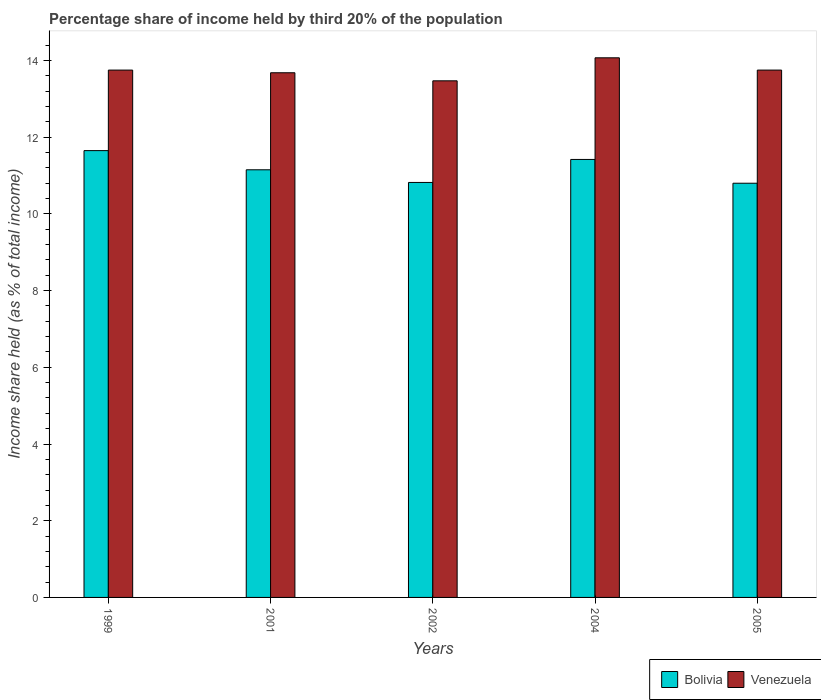How many different coloured bars are there?
Your response must be concise. 2. How many groups of bars are there?
Provide a short and direct response. 5. Are the number of bars on each tick of the X-axis equal?
Provide a short and direct response. Yes. How many bars are there on the 2nd tick from the left?
Provide a short and direct response. 2. What is the label of the 4th group of bars from the left?
Provide a succinct answer. 2004. In how many cases, is the number of bars for a given year not equal to the number of legend labels?
Your answer should be compact. 0. What is the share of income held by third 20% of the population in Bolivia in 2004?
Your answer should be compact. 11.42. Across all years, what is the maximum share of income held by third 20% of the population in Venezuela?
Keep it short and to the point. 14.07. In which year was the share of income held by third 20% of the population in Venezuela minimum?
Offer a very short reply. 2002. What is the total share of income held by third 20% of the population in Bolivia in the graph?
Give a very brief answer. 55.84. What is the difference between the share of income held by third 20% of the population in Venezuela in 1999 and that in 2002?
Offer a terse response. 0.28. What is the difference between the share of income held by third 20% of the population in Venezuela in 1999 and the share of income held by third 20% of the population in Bolivia in 2004?
Keep it short and to the point. 2.33. What is the average share of income held by third 20% of the population in Bolivia per year?
Your answer should be very brief. 11.17. In the year 2004, what is the difference between the share of income held by third 20% of the population in Venezuela and share of income held by third 20% of the population in Bolivia?
Provide a short and direct response. 2.65. In how many years, is the share of income held by third 20% of the population in Bolivia greater than 10 %?
Make the answer very short. 5. Is the share of income held by third 20% of the population in Venezuela in 2001 less than that in 2002?
Make the answer very short. No. What is the difference between the highest and the second highest share of income held by third 20% of the population in Venezuela?
Your answer should be very brief. 0.32. What is the difference between the highest and the lowest share of income held by third 20% of the population in Venezuela?
Provide a short and direct response. 0.6. In how many years, is the share of income held by third 20% of the population in Venezuela greater than the average share of income held by third 20% of the population in Venezuela taken over all years?
Provide a short and direct response. 3. What does the 2nd bar from the left in 2002 represents?
Offer a terse response. Venezuela. How many bars are there?
Offer a terse response. 10. What is the difference between two consecutive major ticks on the Y-axis?
Your answer should be very brief. 2. Does the graph contain any zero values?
Your answer should be compact. No. Where does the legend appear in the graph?
Your answer should be compact. Bottom right. How are the legend labels stacked?
Your answer should be compact. Horizontal. What is the title of the graph?
Offer a terse response. Percentage share of income held by third 20% of the population. What is the label or title of the Y-axis?
Ensure brevity in your answer.  Income share held (as % of total income). What is the Income share held (as % of total income) in Bolivia in 1999?
Provide a short and direct response. 11.65. What is the Income share held (as % of total income) in Venezuela in 1999?
Offer a terse response. 13.75. What is the Income share held (as % of total income) of Bolivia in 2001?
Provide a short and direct response. 11.15. What is the Income share held (as % of total income) of Venezuela in 2001?
Provide a short and direct response. 13.68. What is the Income share held (as % of total income) of Bolivia in 2002?
Provide a short and direct response. 10.82. What is the Income share held (as % of total income) of Venezuela in 2002?
Ensure brevity in your answer.  13.47. What is the Income share held (as % of total income) of Bolivia in 2004?
Offer a terse response. 11.42. What is the Income share held (as % of total income) in Venezuela in 2004?
Your answer should be very brief. 14.07. What is the Income share held (as % of total income) in Venezuela in 2005?
Provide a succinct answer. 13.75. Across all years, what is the maximum Income share held (as % of total income) of Bolivia?
Your response must be concise. 11.65. Across all years, what is the maximum Income share held (as % of total income) of Venezuela?
Your response must be concise. 14.07. Across all years, what is the minimum Income share held (as % of total income) in Bolivia?
Offer a very short reply. 10.8. Across all years, what is the minimum Income share held (as % of total income) in Venezuela?
Ensure brevity in your answer.  13.47. What is the total Income share held (as % of total income) of Bolivia in the graph?
Your response must be concise. 55.84. What is the total Income share held (as % of total income) in Venezuela in the graph?
Your answer should be compact. 68.72. What is the difference between the Income share held (as % of total income) in Venezuela in 1999 and that in 2001?
Give a very brief answer. 0.07. What is the difference between the Income share held (as % of total income) of Bolivia in 1999 and that in 2002?
Provide a succinct answer. 0.83. What is the difference between the Income share held (as % of total income) of Venezuela in 1999 and that in 2002?
Keep it short and to the point. 0.28. What is the difference between the Income share held (as % of total income) of Bolivia in 1999 and that in 2004?
Offer a terse response. 0.23. What is the difference between the Income share held (as % of total income) of Venezuela in 1999 and that in 2004?
Give a very brief answer. -0.32. What is the difference between the Income share held (as % of total income) in Bolivia in 2001 and that in 2002?
Your answer should be very brief. 0.33. What is the difference between the Income share held (as % of total income) of Venezuela in 2001 and that in 2002?
Offer a very short reply. 0.21. What is the difference between the Income share held (as % of total income) of Bolivia in 2001 and that in 2004?
Give a very brief answer. -0.27. What is the difference between the Income share held (as % of total income) in Venezuela in 2001 and that in 2004?
Give a very brief answer. -0.39. What is the difference between the Income share held (as % of total income) in Venezuela in 2001 and that in 2005?
Offer a terse response. -0.07. What is the difference between the Income share held (as % of total income) in Venezuela in 2002 and that in 2004?
Provide a short and direct response. -0.6. What is the difference between the Income share held (as % of total income) in Venezuela in 2002 and that in 2005?
Your answer should be compact. -0.28. What is the difference between the Income share held (as % of total income) in Bolivia in 2004 and that in 2005?
Your answer should be compact. 0.62. What is the difference between the Income share held (as % of total income) in Venezuela in 2004 and that in 2005?
Your answer should be compact. 0.32. What is the difference between the Income share held (as % of total income) in Bolivia in 1999 and the Income share held (as % of total income) in Venezuela in 2001?
Keep it short and to the point. -2.03. What is the difference between the Income share held (as % of total income) of Bolivia in 1999 and the Income share held (as % of total income) of Venezuela in 2002?
Offer a very short reply. -1.82. What is the difference between the Income share held (as % of total income) of Bolivia in 1999 and the Income share held (as % of total income) of Venezuela in 2004?
Keep it short and to the point. -2.42. What is the difference between the Income share held (as % of total income) in Bolivia in 1999 and the Income share held (as % of total income) in Venezuela in 2005?
Make the answer very short. -2.1. What is the difference between the Income share held (as % of total income) of Bolivia in 2001 and the Income share held (as % of total income) of Venezuela in 2002?
Ensure brevity in your answer.  -2.32. What is the difference between the Income share held (as % of total income) in Bolivia in 2001 and the Income share held (as % of total income) in Venezuela in 2004?
Your answer should be compact. -2.92. What is the difference between the Income share held (as % of total income) of Bolivia in 2002 and the Income share held (as % of total income) of Venezuela in 2004?
Ensure brevity in your answer.  -3.25. What is the difference between the Income share held (as % of total income) in Bolivia in 2002 and the Income share held (as % of total income) in Venezuela in 2005?
Give a very brief answer. -2.93. What is the difference between the Income share held (as % of total income) of Bolivia in 2004 and the Income share held (as % of total income) of Venezuela in 2005?
Your answer should be compact. -2.33. What is the average Income share held (as % of total income) of Bolivia per year?
Your response must be concise. 11.17. What is the average Income share held (as % of total income) in Venezuela per year?
Your answer should be compact. 13.74. In the year 2001, what is the difference between the Income share held (as % of total income) in Bolivia and Income share held (as % of total income) in Venezuela?
Keep it short and to the point. -2.53. In the year 2002, what is the difference between the Income share held (as % of total income) of Bolivia and Income share held (as % of total income) of Venezuela?
Your answer should be compact. -2.65. In the year 2004, what is the difference between the Income share held (as % of total income) of Bolivia and Income share held (as % of total income) of Venezuela?
Ensure brevity in your answer.  -2.65. In the year 2005, what is the difference between the Income share held (as % of total income) of Bolivia and Income share held (as % of total income) of Venezuela?
Provide a short and direct response. -2.95. What is the ratio of the Income share held (as % of total income) of Bolivia in 1999 to that in 2001?
Offer a terse response. 1.04. What is the ratio of the Income share held (as % of total income) in Venezuela in 1999 to that in 2001?
Ensure brevity in your answer.  1.01. What is the ratio of the Income share held (as % of total income) of Bolivia in 1999 to that in 2002?
Offer a terse response. 1.08. What is the ratio of the Income share held (as % of total income) in Venezuela in 1999 to that in 2002?
Keep it short and to the point. 1.02. What is the ratio of the Income share held (as % of total income) in Bolivia in 1999 to that in 2004?
Provide a succinct answer. 1.02. What is the ratio of the Income share held (as % of total income) of Venezuela in 1999 to that in 2004?
Ensure brevity in your answer.  0.98. What is the ratio of the Income share held (as % of total income) of Bolivia in 1999 to that in 2005?
Your answer should be compact. 1.08. What is the ratio of the Income share held (as % of total income) of Venezuela in 1999 to that in 2005?
Offer a very short reply. 1. What is the ratio of the Income share held (as % of total income) of Bolivia in 2001 to that in 2002?
Offer a terse response. 1.03. What is the ratio of the Income share held (as % of total income) of Venezuela in 2001 to that in 2002?
Provide a short and direct response. 1.02. What is the ratio of the Income share held (as % of total income) in Bolivia in 2001 to that in 2004?
Provide a short and direct response. 0.98. What is the ratio of the Income share held (as % of total income) of Venezuela in 2001 to that in 2004?
Provide a succinct answer. 0.97. What is the ratio of the Income share held (as % of total income) in Bolivia in 2001 to that in 2005?
Provide a short and direct response. 1.03. What is the ratio of the Income share held (as % of total income) in Venezuela in 2001 to that in 2005?
Keep it short and to the point. 0.99. What is the ratio of the Income share held (as % of total income) of Bolivia in 2002 to that in 2004?
Provide a succinct answer. 0.95. What is the ratio of the Income share held (as % of total income) in Venezuela in 2002 to that in 2004?
Give a very brief answer. 0.96. What is the ratio of the Income share held (as % of total income) of Bolivia in 2002 to that in 2005?
Ensure brevity in your answer.  1. What is the ratio of the Income share held (as % of total income) of Venezuela in 2002 to that in 2005?
Provide a short and direct response. 0.98. What is the ratio of the Income share held (as % of total income) in Bolivia in 2004 to that in 2005?
Your response must be concise. 1.06. What is the ratio of the Income share held (as % of total income) of Venezuela in 2004 to that in 2005?
Your answer should be compact. 1.02. What is the difference between the highest and the second highest Income share held (as % of total income) in Bolivia?
Make the answer very short. 0.23. What is the difference between the highest and the second highest Income share held (as % of total income) of Venezuela?
Your answer should be very brief. 0.32. What is the difference between the highest and the lowest Income share held (as % of total income) in Bolivia?
Ensure brevity in your answer.  0.85. What is the difference between the highest and the lowest Income share held (as % of total income) of Venezuela?
Your response must be concise. 0.6. 